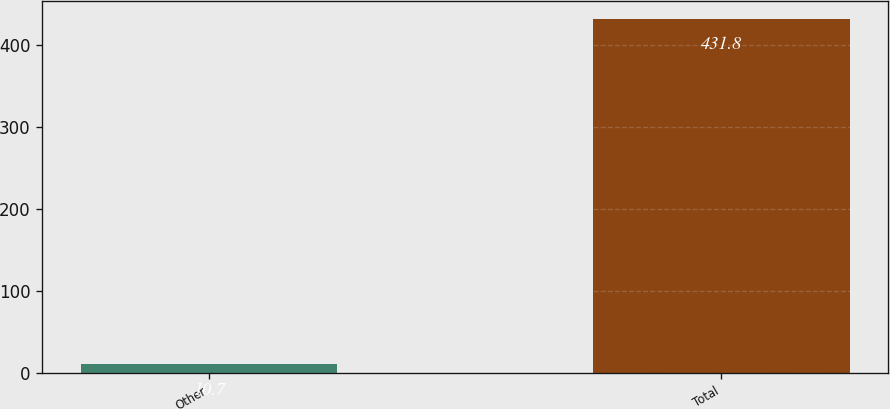<chart> <loc_0><loc_0><loc_500><loc_500><bar_chart><fcel>Other<fcel>Total<nl><fcel>10.7<fcel>431.8<nl></chart> 